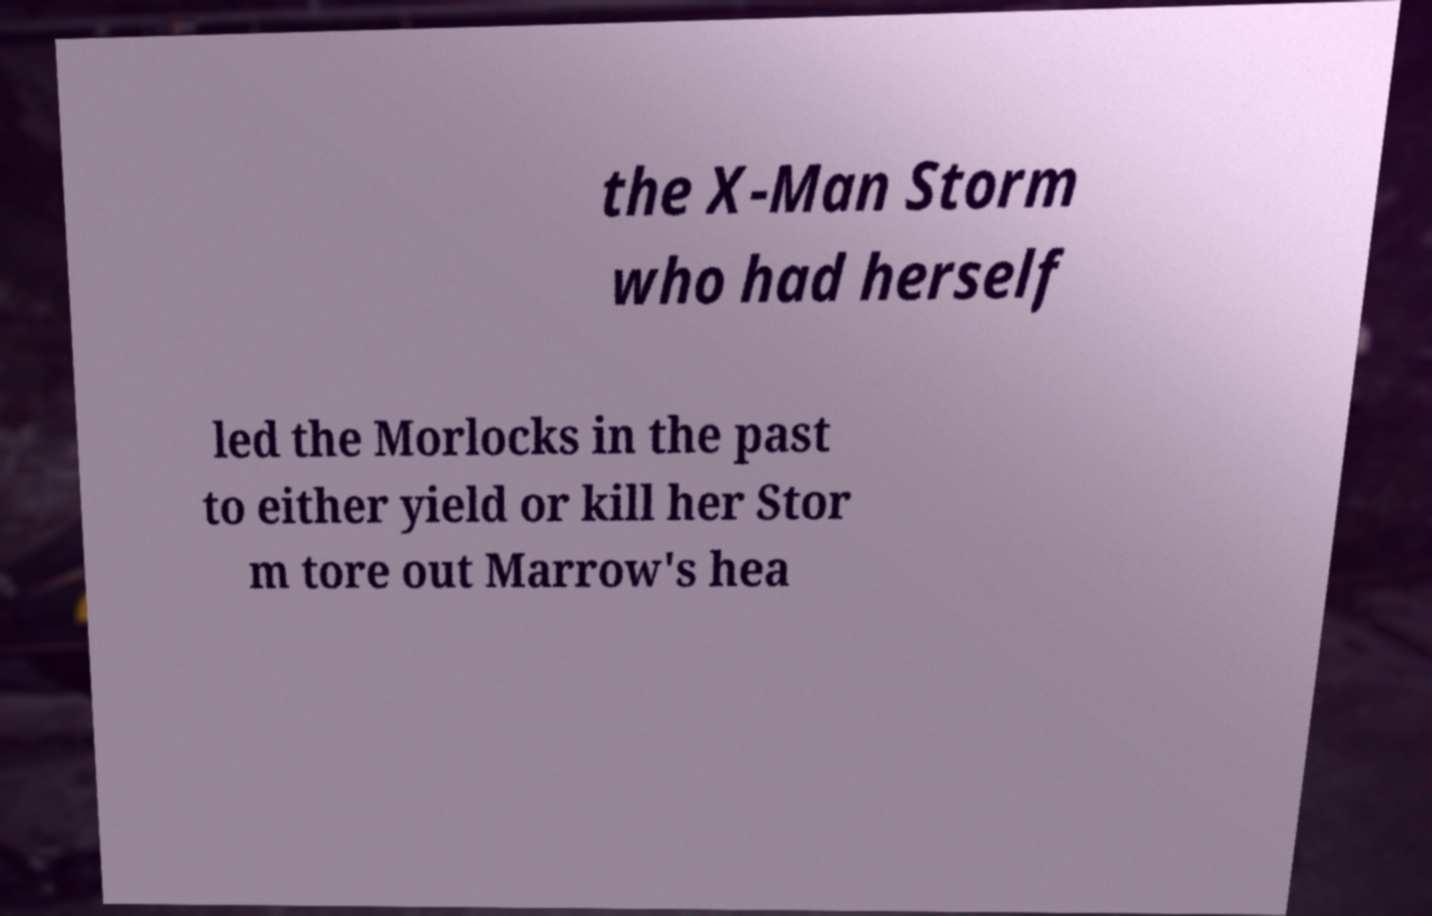Can you accurately transcribe the text from the provided image for me? the X-Man Storm who had herself led the Morlocks in the past to either yield or kill her Stor m tore out Marrow's hea 